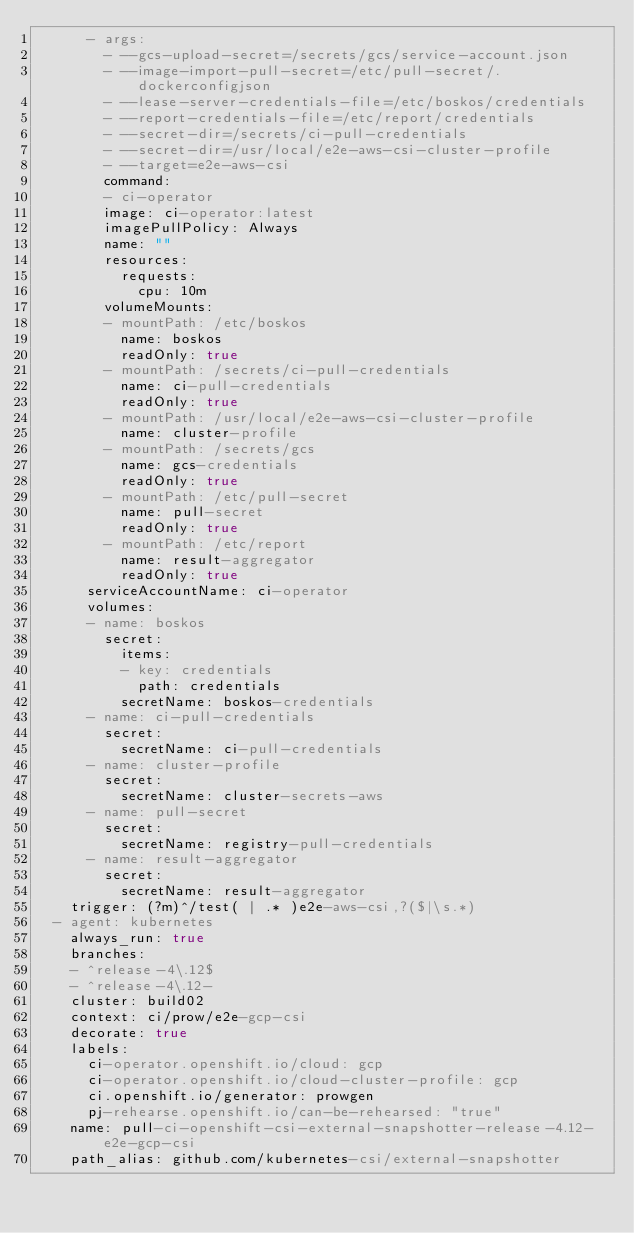<code> <loc_0><loc_0><loc_500><loc_500><_YAML_>      - args:
        - --gcs-upload-secret=/secrets/gcs/service-account.json
        - --image-import-pull-secret=/etc/pull-secret/.dockerconfigjson
        - --lease-server-credentials-file=/etc/boskos/credentials
        - --report-credentials-file=/etc/report/credentials
        - --secret-dir=/secrets/ci-pull-credentials
        - --secret-dir=/usr/local/e2e-aws-csi-cluster-profile
        - --target=e2e-aws-csi
        command:
        - ci-operator
        image: ci-operator:latest
        imagePullPolicy: Always
        name: ""
        resources:
          requests:
            cpu: 10m
        volumeMounts:
        - mountPath: /etc/boskos
          name: boskos
          readOnly: true
        - mountPath: /secrets/ci-pull-credentials
          name: ci-pull-credentials
          readOnly: true
        - mountPath: /usr/local/e2e-aws-csi-cluster-profile
          name: cluster-profile
        - mountPath: /secrets/gcs
          name: gcs-credentials
          readOnly: true
        - mountPath: /etc/pull-secret
          name: pull-secret
          readOnly: true
        - mountPath: /etc/report
          name: result-aggregator
          readOnly: true
      serviceAccountName: ci-operator
      volumes:
      - name: boskos
        secret:
          items:
          - key: credentials
            path: credentials
          secretName: boskos-credentials
      - name: ci-pull-credentials
        secret:
          secretName: ci-pull-credentials
      - name: cluster-profile
        secret:
          secretName: cluster-secrets-aws
      - name: pull-secret
        secret:
          secretName: registry-pull-credentials
      - name: result-aggregator
        secret:
          secretName: result-aggregator
    trigger: (?m)^/test( | .* )e2e-aws-csi,?($|\s.*)
  - agent: kubernetes
    always_run: true
    branches:
    - ^release-4\.12$
    - ^release-4\.12-
    cluster: build02
    context: ci/prow/e2e-gcp-csi
    decorate: true
    labels:
      ci-operator.openshift.io/cloud: gcp
      ci-operator.openshift.io/cloud-cluster-profile: gcp
      ci.openshift.io/generator: prowgen
      pj-rehearse.openshift.io/can-be-rehearsed: "true"
    name: pull-ci-openshift-csi-external-snapshotter-release-4.12-e2e-gcp-csi
    path_alias: github.com/kubernetes-csi/external-snapshotter</code> 